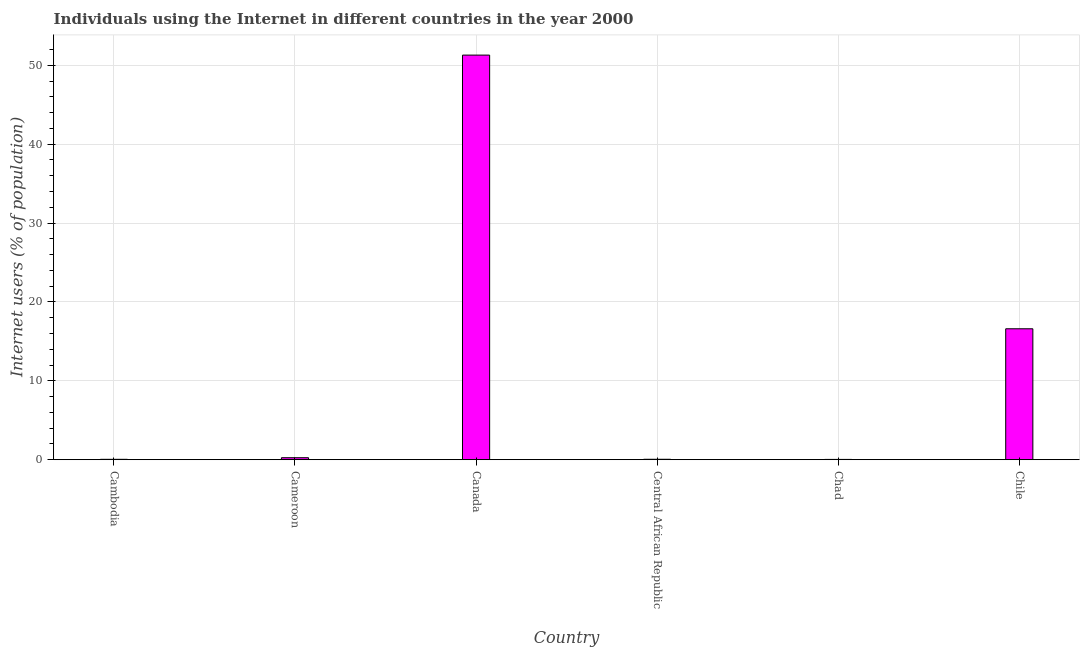Does the graph contain any zero values?
Give a very brief answer. No. What is the title of the graph?
Your answer should be very brief. Individuals using the Internet in different countries in the year 2000. What is the label or title of the Y-axis?
Offer a terse response. Internet users (% of population). What is the number of internet users in Cambodia?
Your answer should be very brief. 0.05. Across all countries, what is the maximum number of internet users?
Your answer should be compact. 51.3. Across all countries, what is the minimum number of internet users?
Provide a succinct answer. 0.04. In which country was the number of internet users maximum?
Give a very brief answer. Canada. In which country was the number of internet users minimum?
Your answer should be very brief. Chad. What is the sum of the number of internet users?
Offer a terse response. 68.29. What is the difference between the number of internet users in Central African Republic and Chile?
Make the answer very short. -16.55. What is the average number of internet users per country?
Ensure brevity in your answer.  11.38. What is the median number of internet users?
Keep it short and to the point. 0.15. What is the ratio of the number of internet users in Cameroon to that in Chad?
Ensure brevity in your answer.  7.06. Is the difference between the number of internet users in Chad and Chile greater than the difference between any two countries?
Provide a succinct answer. No. What is the difference between the highest and the second highest number of internet users?
Ensure brevity in your answer.  34.7. Is the sum of the number of internet users in Cameroon and Chad greater than the maximum number of internet users across all countries?
Give a very brief answer. No. What is the difference between the highest and the lowest number of internet users?
Provide a succinct answer. 51.26. What is the difference between two consecutive major ticks on the Y-axis?
Provide a short and direct response. 10. What is the Internet users (% of population) of Cambodia?
Offer a terse response. 0.05. What is the Internet users (% of population) in Cameroon?
Provide a succinct answer. 0.25. What is the Internet users (% of population) of Canada?
Provide a short and direct response. 51.3. What is the Internet users (% of population) of Central African Republic?
Make the answer very short. 0.05. What is the Internet users (% of population) of Chad?
Offer a very short reply. 0.04. What is the Internet users (% of population) of Chile?
Provide a short and direct response. 16.6. What is the difference between the Internet users (% of population) in Cambodia and Cameroon?
Ensure brevity in your answer.  -0.21. What is the difference between the Internet users (% of population) in Cambodia and Canada?
Make the answer very short. -51.25. What is the difference between the Internet users (% of population) in Cambodia and Central African Republic?
Your answer should be compact. -0.01. What is the difference between the Internet users (% of population) in Cambodia and Chad?
Keep it short and to the point. 0.01. What is the difference between the Internet users (% of population) in Cambodia and Chile?
Provide a short and direct response. -16.55. What is the difference between the Internet users (% of population) in Cameroon and Canada?
Provide a succinct answer. -51.05. What is the difference between the Internet users (% of population) in Cameroon and Central African Republic?
Your answer should be compact. 0.2. What is the difference between the Internet users (% of population) in Cameroon and Chad?
Offer a very short reply. 0.22. What is the difference between the Internet users (% of population) in Cameroon and Chile?
Keep it short and to the point. -16.35. What is the difference between the Internet users (% of population) in Canada and Central African Republic?
Keep it short and to the point. 51.25. What is the difference between the Internet users (% of population) in Canada and Chad?
Offer a terse response. 51.26. What is the difference between the Internet users (% of population) in Canada and Chile?
Keep it short and to the point. 34.7. What is the difference between the Internet users (% of population) in Central African Republic and Chad?
Your response must be concise. 0.02. What is the difference between the Internet users (% of population) in Central African Republic and Chile?
Provide a succinct answer. -16.55. What is the difference between the Internet users (% of population) in Chad and Chile?
Your answer should be very brief. -16.56. What is the ratio of the Internet users (% of population) in Cambodia to that in Cameroon?
Keep it short and to the point. 0.19. What is the ratio of the Internet users (% of population) in Cambodia to that in Canada?
Provide a succinct answer. 0. What is the ratio of the Internet users (% of population) in Cambodia to that in Central African Republic?
Keep it short and to the point. 0.88. What is the ratio of the Internet users (% of population) in Cambodia to that in Chad?
Ensure brevity in your answer.  1.32. What is the ratio of the Internet users (% of population) in Cambodia to that in Chile?
Offer a very short reply. 0. What is the ratio of the Internet users (% of population) in Cameroon to that in Canada?
Make the answer very short. 0.01. What is the ratio of the Internet users (% of population) in Cameroon to that in Central African Republic?
Offer a terse response. 4.72. What is the ratio of the Internet users (% of population) in Cameroon to that in Chad?
Give a very brief answer. 7.06. What is the ratio of the Internet users (% of population) in Cameroon to that in Chile?
Your response must be concise. 0.01. What is the ratio of the Internet users (% of population) in Canada to that in Central African Republic?
Give a very brief answer. 960.78. What is the ratio of the Internet users (% of population) in Canada to that in Chad?
Offer a terse response. 1436.69. What is the ratio of the Internet users (% of population) in Canada to that in Chile?
Offer a terse response. 3.09. What is the ratio of the Internet users (% of population) in Central African Republic to that in Chad?
Provide a succinct answer. 1.5. What is the ratio of the Internet users (% of population) in Central African Republic to that in Chile?
Give a very brief answer. 0. What is the ratio of the Internet users (% of population) in Chad to that in Chile?
Give a very brief answer. 0. 